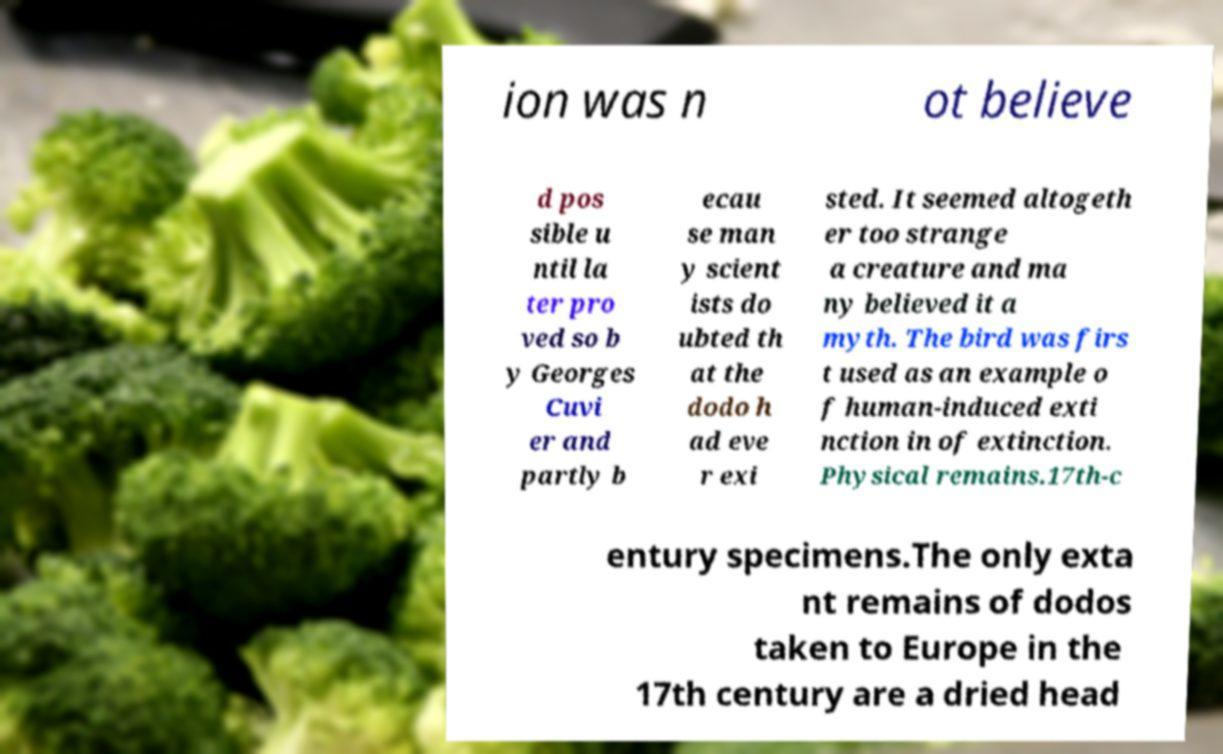Could you extract and type out the text from this image? ion was n ot believe d pos sible u ntil la ter pro ved so b y Georges Cuvi er and partly b ecau se man y scient ists do ubted th at the dodo h ad eve r exi sted. It seemed altogeth er too strange a creature and ma ny believed it a myth. The bird was firs t used as an example o f human-induced exti nction in of extinction. Physical remains.17th-c entury specimens.The only exta nt remains of dodos taken to Europe in the 17th century are a dried head 